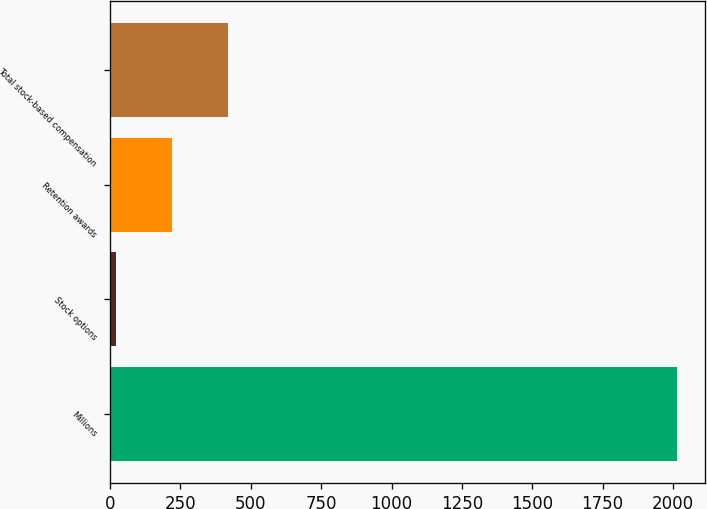<chart> <loc_0><loc_0><loc_500><loc_500><bar_chart><fcel>Millions<fcel>Stock options<fcel>Retention awards<fcel>Total stock-based compensation<nl><fcel>2014<fcel>21<fcel>220.3<fcel>419.6<nl></chart> 